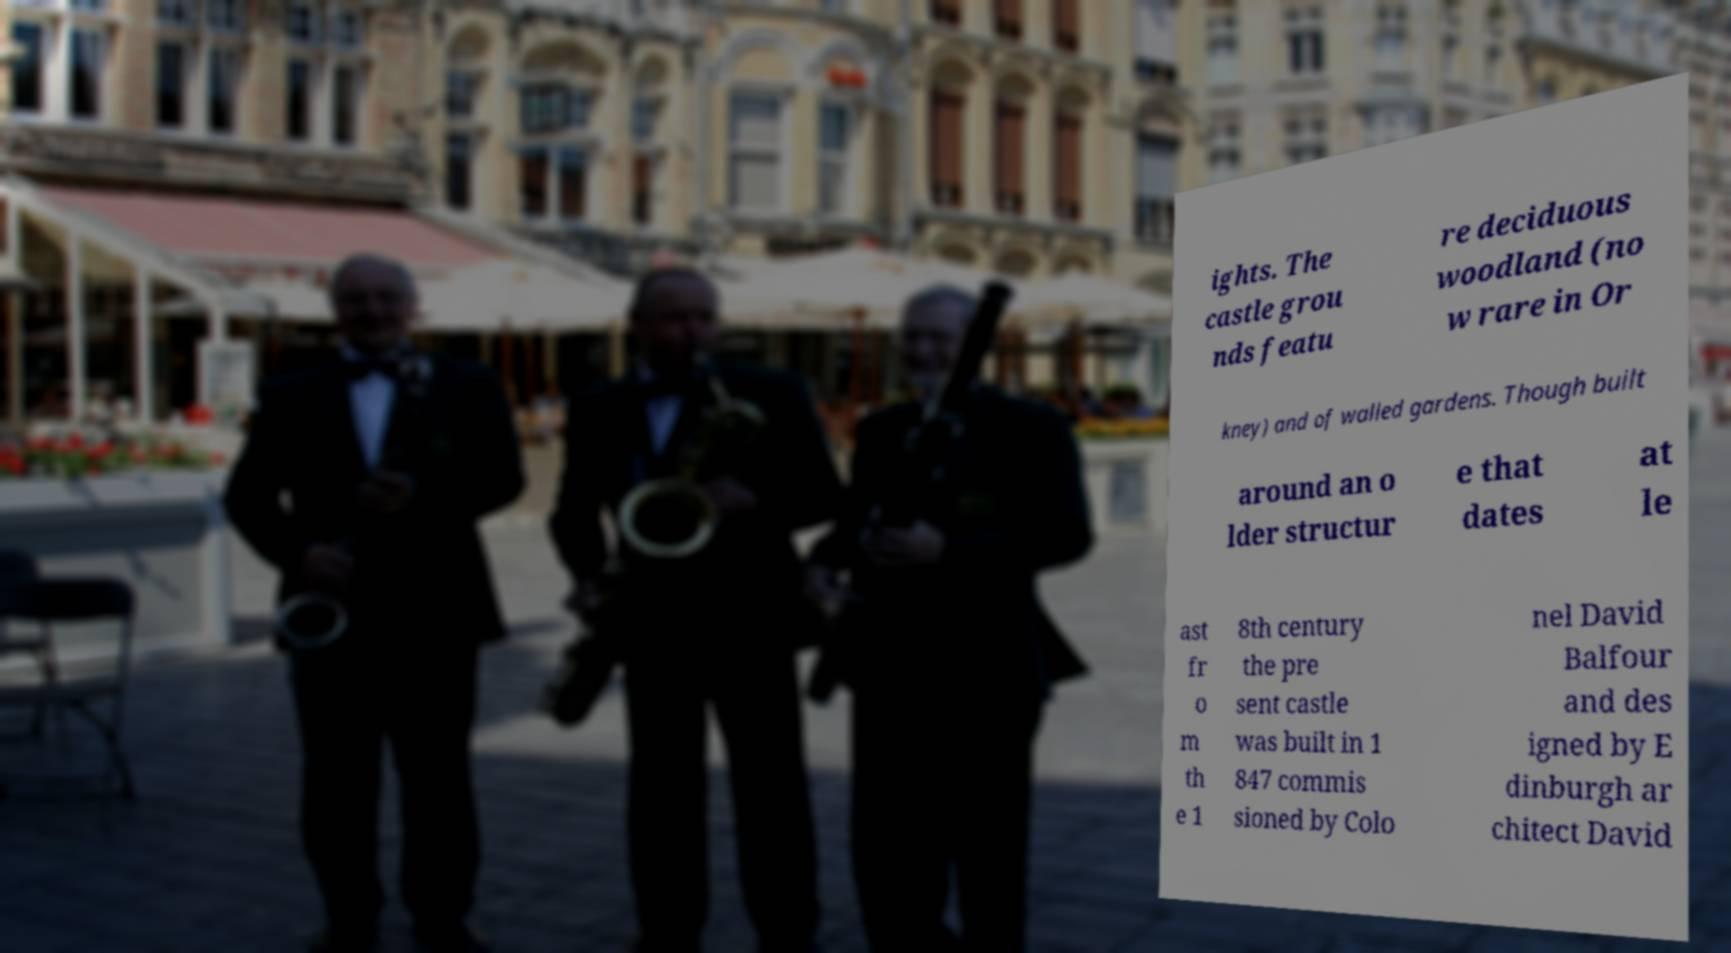There's text embedded in this image that I need extracted. Can you transcribe it verbatim? ights. The castle grou nds featu re deciduous woodland (no w rare in Or kney) and of walled gardens. Though built around an o lder structur e that dates at le ast fr o m th e 1 8th century the pre sent castle was built in 1 847 commis sioned by Colo nel David Balfour and des igned by E dinburgh ar chitect David 